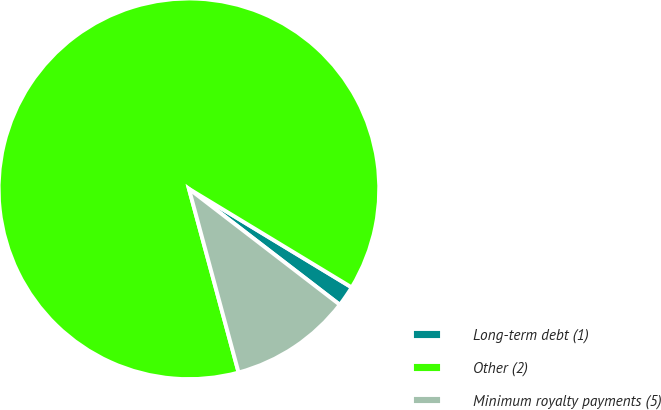<chart> <loc_0><loc_0><loc_500><loc_500><pie_chart><fcel>Long-term debt (1)<fcel>Other (2)<fcel>Minimum royalty payments (5)<nl><fcel>1.76%<fcel>87.87%<fcel>10.37%<nl></chart> 